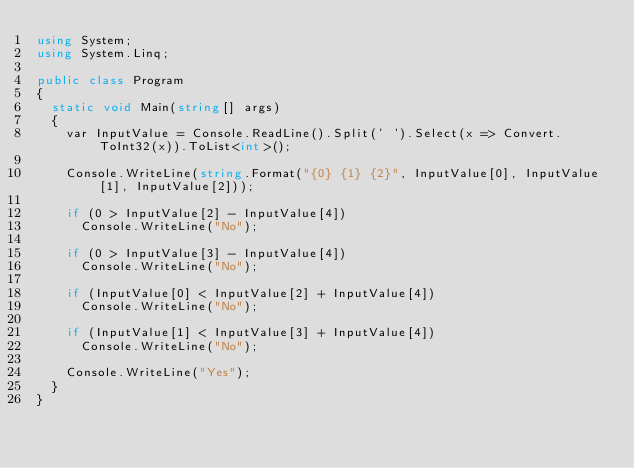<code> <loc_0><loc_0><loc_500><loc_500><_C#_>using System;
using System.Linq;

public class Program
{
	static void Main(string[] args)
	{
		var InputValue = Console.ReadLine().Split(' ').Select(x => Convert.ToInt32(x)).ToList<int>();

		Console.WriteLine(string.Format("{0} {1} {2}", InputValue[0], InputValue[1], InputValue[2]));

		if (0 > InputValue[2] - InputValue[4])
			Console.WriteLine("No");

		if (0 > InputValue[3] - InputValue[4])
			Console.WriteLine("No");

		if (InputValue[0] < InputValue[2] + InputValue[4])
			Console.WriteLine("No");

		if (InputValue[1] < InputValue[3] + InputValue[4])
			Console.WriteLine("No");

		Console.WriteLine("Yes");
	}
}




</code> 